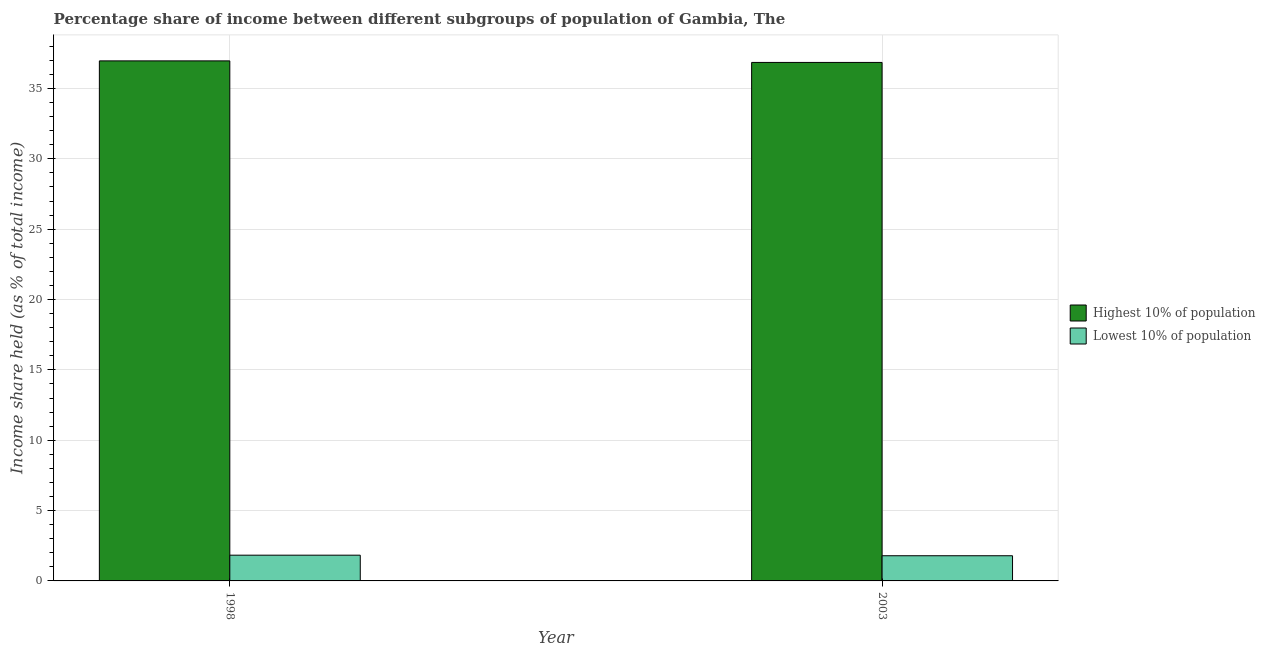How many different coloured bars are there?
Keep it short and to the point. 2. How many groups of bars are there?
Provide a succinct answer. 2. Are the number of bars on each tick of the X-axis equal?
Offer a very short reply. Yes. How many bars are there on the 1st tick from the left?
Give a very brief answer. 2. How many bars are there on the 2nd tick from the right?
Make the answer very short. 2. What is the label of the 1st group of bars from the left?
Ensure brevity in your answer.  1998. In how many cases, is the number of bars for a given year not equal to the number of legend labels?
Offer a terse response. 0. What is the income share held by lowest 10% of the population in 2003?
Your answer should be compact. 1.79. Across all years, what is the maximum income share held by lowest 10% of the population?
Give a very brief answer. 1.83. Across all years, what is the minimum income share held by lowest 10% of the population?
Offer a terse response. 1.79. In which year was the income share held by lowest 10% of the population maximum?
Offer a very short reply. 1998. In which year was the income share held by highest 10% of the population minimum?
Your response must be concise. 2003. What is the total income share held by lowest 10% of the population in the graph?
Offer a terse response. 3.62. What is the difference between the income share held by highest 10% of the population in 1998 and that in 2003?
Your response must be concise. 0.11. What is the difference between the income share held by lowest 10% of the population in 1998 and the income share held by highest 10% of the population in 2003?
Ensure brevity in your answer.  0.04. What is the average income share held by highest 10% of the population per year?
Your answer should be very brief. 36.91. In the year 1998, what is the difference between the income share held by lowest 10% of the population and income share held by highest 10% of the population?
Provide a succinct answer. 0. In how many years, is the income share held by lowest 10% of the population greater than 22 %?
Offer a very short reply. 0. What is the ratio of the income share held by lowest 10% of the population in 1998 to that in 2003?
Provide a short and direct response. 1.02. In how many years, is the income share held by highest 10% of the population greater than the average income share held by highest 10% of the population taken over all years?
Make the answer very short. 1. What does the 2nd bar from the left in 1998 represents?
Your answer should be compact. Lowest 10% of population. What does the 2nd bar from the right in 2003 represents?
Keep it short and to the point. Highest 10% of population. Are all the bars in the graph horizontal?
Your answer should be very brief. No. Does the graph contain any zero values?
Your answer should be very brief. No. Does the graph contain grids?
Offer a terse response. Yes. Where does the legend appear in the graph?
Offer a very short reply. Center right. How are the legend labels stacked?
Make the answer very short. Vertical. What is the title of the graph?
Your answer should be very brief. Percentage share of income between different subgroups of population of Gambia, The. What is the label or title of the X-axis?
Offer a very short reply. Year. What is the label or title of the Y-axis?
Offer a very short reply. Income share held (as % of total income). What is the Income share held (as % of total income) of Highest 10% of population in 1998?
Your response must be concise. 36.96. What is the Income share held (as % of total income) of Lowest 10% of population in 1998?
Keep it short and to the point. 1.83. What is the Income share held (as % of total income) of Highest 10% of population in 2003?
Offer a very short reply. 36.85. What is the Income share held (as % of total income) of Lowest 10% of population in 2003?
Keep it short and to the point. 1.79. Across all years, what is the maximum Income share held (as % of total income) in Highest 10% of population?
Your answer should be compact. 36.96. Across all years, what is the maximum Income share held (as % of total income) in Lowest 10% of population?
Keep it short and to the point. 1.83. Across all years, what is the minimum Income share held (as % of total income) of Highest 10% of population?
Give a very brief answer. 36.85. Across all years, what is the minimum Income share held (as % of total income) of Lowest 10% of population?
Your answer should be very brief. 1.79. What is the total Income share held (as % of total income) of Highest 10% of population in the graph?
Keep it short and to the point. 73.81. What is the total Income share held (as % of total income) of Lowest 10% of population in the graph?
Your answer should be compact. 3.62. What is the difference between the Income share held (as % of total income) in Highest 10% of population in 1998 and that in 2003?
Offer a terse response. 0.11. What is the difference between the Income share held (as % of total income) of Highest 10% of population in 1998 and the Income share held (as % of total income) of Lowest 10% of population in 2003?
Your answer should be very brief. 35.17. What is the average Income share held (as % of total income) of Highest 10% of population per year?
Your answer should be compact. 36.91. What is the average Income share held (as % of total income) in Lowest 10% of population per year?
Give a very brief answer. 1.81. In the year 1998, what is the difference between the Income share held (as % of total income) in Highest 10% of population and Income share held (as % of total income) in Lowest 10% of population?
Offer a very short reply. 35.13. In the year 2003, what is the difference between the Income share held (as % of total income) of Highest 10% of population and Income share held (as % of total income) of Lowest 10% of population?
Offer a terse response. 35.06. What is the ratio of the Income share held (as % of total income) in Highest 10% of population in 1998 to that in 2003?
Ensure brevity in your answer.  1. What is the ratio of the Income share held (as % of total income) in Lowest 10% of population in 1998 to that in 2003?
Give a very brief answer. 1.02. What is the difference between the highest and the second highest Income share held (as % of total income) of Highest 10% of population?
Offer a terse response. 0.11. What is the difference between the highest and the second highest Income share held (as % of total income) of Lowest 10% of population?
Your answer should be compact. 0.04. What is the difference between the highest and the lowest Income share held (as % of total income) in Highest 10% of population?
Your response must be concise. 0.11. 